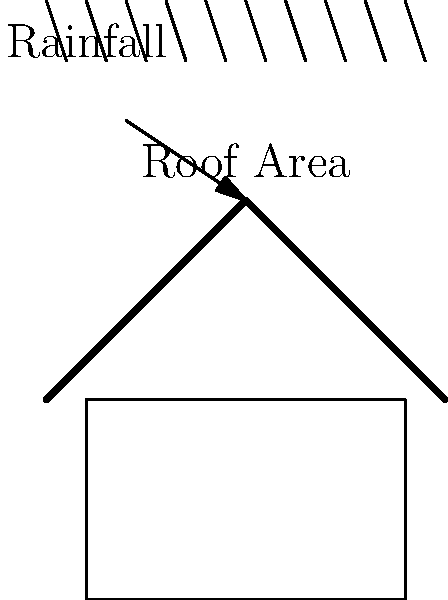As a parenting influencer interested in sustainable living, you want to design a rainwater harvesting system for your family home. If your roof area is 150 square meters and the average annual rainfall in your area is 800 mm, how many liters of water can you potentially collect in a year? Assume a collection efficiency of 80%. To calculate the potential water collection from a rainwater harvesting system, we'll follow these steps:

1. Convert the rainfall from mm to meters:
   $800 \text{ mm} = 0.8 \text{ m}$

2. Calculate the volume of water that falls on the roof:
   $\text{Volume} = \text{Roof Area} \times \text{Rainfall}$
   $V = 150 \text{ m}^2 \times 0.8 \text{ m} = 120 \text{ m}^3$

3. Convert cubic meters to liters:
   $1 \text{ m}^3 = 1000 \text{ liters}$
   $120 \text{ m}^3 = 120,000 \text{ liters}$

4. Apply the collection efficiency:
   $\text{Collected Water} = \text{Total Water} \times \text{Efficiency}$
   $\text{Collected Water} = 120,000 \text{ liters} \times 0.80 = 96,000 \text{ liters}$

Therefore, with an 80% collection efficiency, you can potentially collect 96,000 liters of water in a year.
Answer: 96,000 liters 